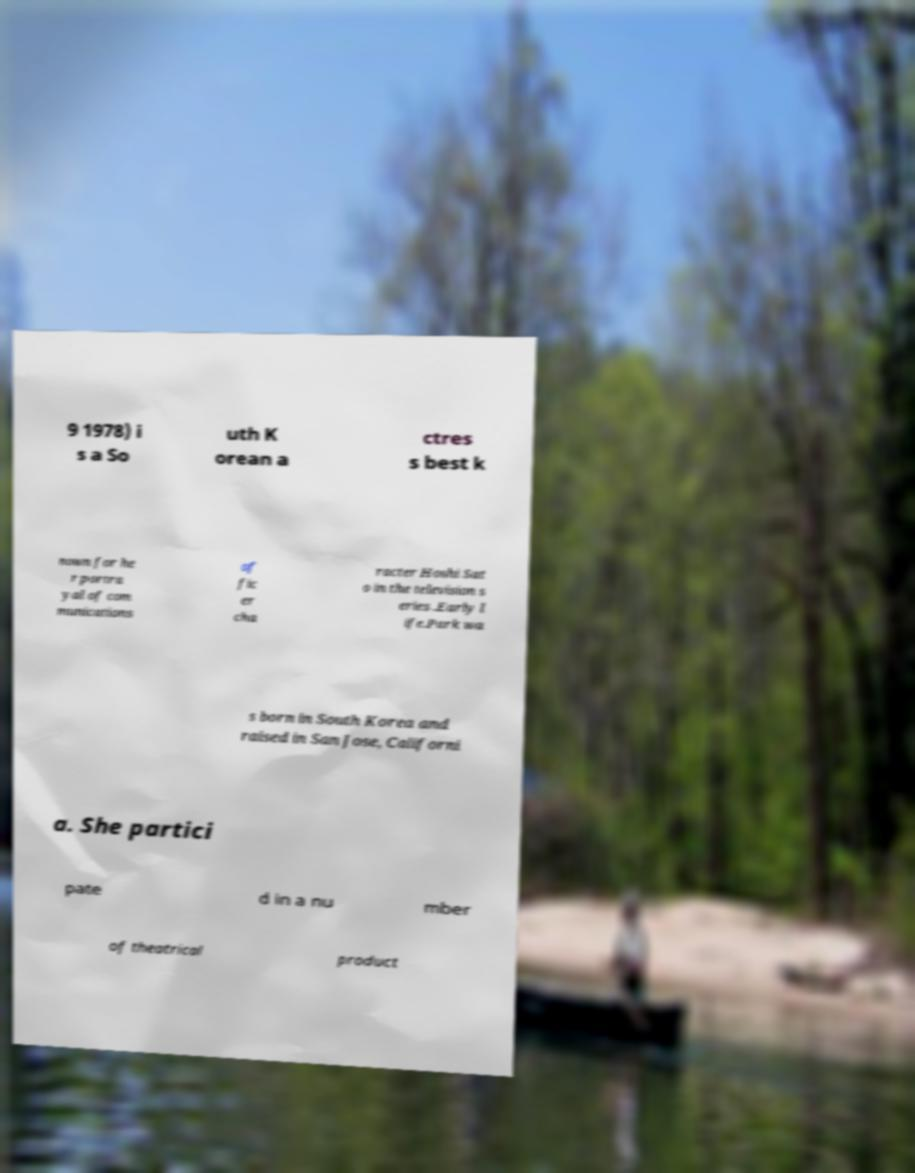Could you assist in decoding the text presented in this image and type it out clearly? 9 1978) i s a So uth K orean a ctres s best k nown for he r portra yal of com munications of fic er cha racter Hoshi Sat o in the television s eries .Early l ife.Park wa s born in South Korea and raised in San Jose, Californi a. She partici pate d in a nu mber of theatrical product 